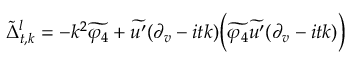<formula> <loc_0><loc_0><loc_500><loc_500>\tilde { \Delta } _ { t , k } ^ { l } = - k ^ { 2 } \widetilde { \varphi _ { 4 } } + \widetilde { u ^ { \prime } } ( \partial _ { v } - i t k ) \left ( \widetilde { \varphi _ { 4 } } \widetilde { u ^ { \prime } } ( \partial _ { v } - i t k ) \right )</formula> 